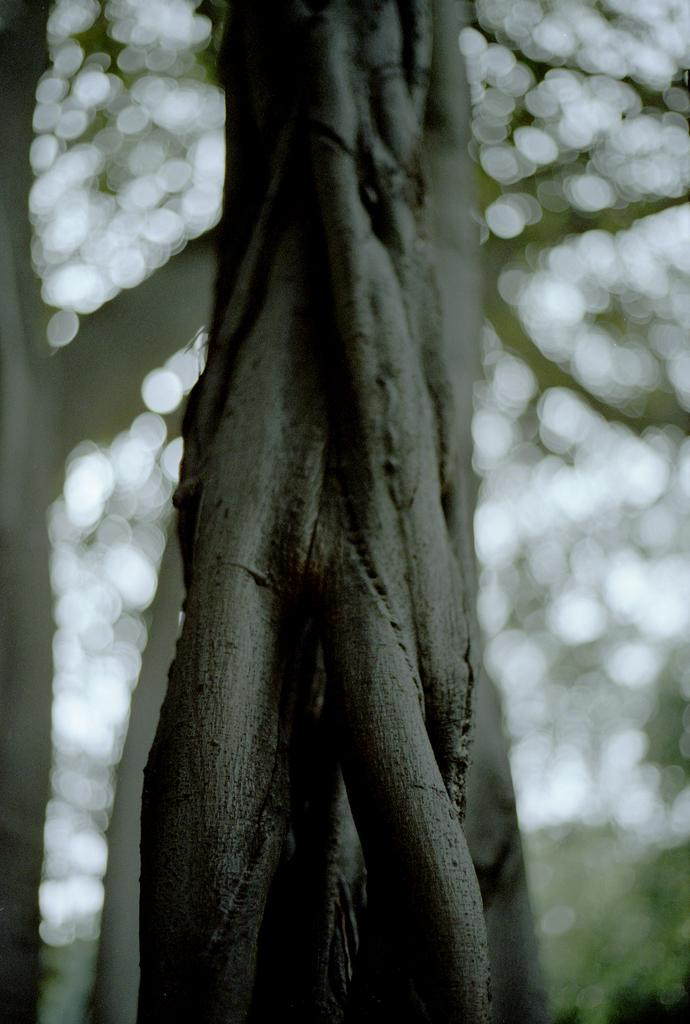What type of natural elements can be seen in the image? There are trees in the image. How would you describe the background of the image? The background of the image is blurred. How many chairs are placed around the surprise in the image? There are no chairs or surprises present in the image; it only features trees and a blurred background. 